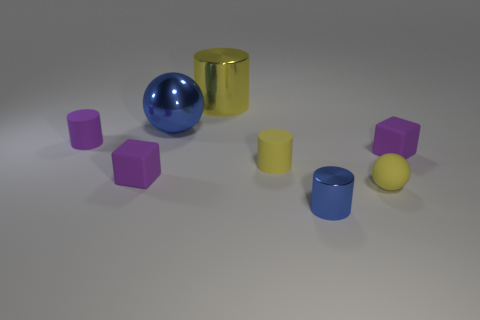Are there any cubes of the same size as the shiny sphere?
Offer a very short reply. No. There is a block that is right of the yellow rubber cylinder; what material is it?
Ensure brevity in your answer.  Rubber. The big thing that is the same material as the large sphere is what color?
Your answer should be very brief. Yellow. What number of metal things are either purple objects or purple cylinders?
Make the answer very short. 0. There is another thing that is the same size as the yellow metal thing; what is its shape?
Offer a very short reply. Sphere. How many objects are tiny purple rubber objects that are left of the large blue metallic ball or small blocks that are to the right of the big yellow cylinder?
Provide a short and direct response. 3. There is a purple cylinder that is the same size as the yellow sphere; what material is it?
Give a very brief answer. Rubber. How many other objects are the same material as the small yellow ball?
Provide a short and direct response. 4. Are there an equal number of tiny rubber balls that are behind the large yellow shiny cylinder and big yellow metal objects that are right of the small yellow matte cylinder?
Your response must be concise. Yes. How many blue things are metallic things or large spheres?
Offer a terse response. 2. 